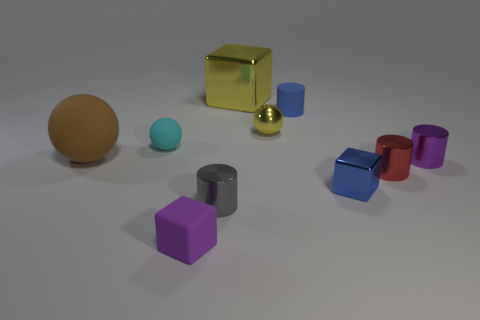Subtract all small blocks. How many blocks are left? 1 Subtract all purple blocks. How many blocks are left? 2 Subtract 3 cubes. How many cubes are left? 0 Subtract all tiny yellow things. Subtract all tiny blocks. How many objects are left? 7 Add 2 large spheres. How many large spheres are left? 3 Add 6 green metal objects. How many green metal objects exist? 6 Subtract 0 blue balls. How many objects are left? 10 Subtract all cylinders. How many objects are left? 6 Subtract all yellow cylinders. Subtract all yellow blocks. How many cylinders are left? 4 Subtract all yellow cylinders. How many red blocks are left? 0 